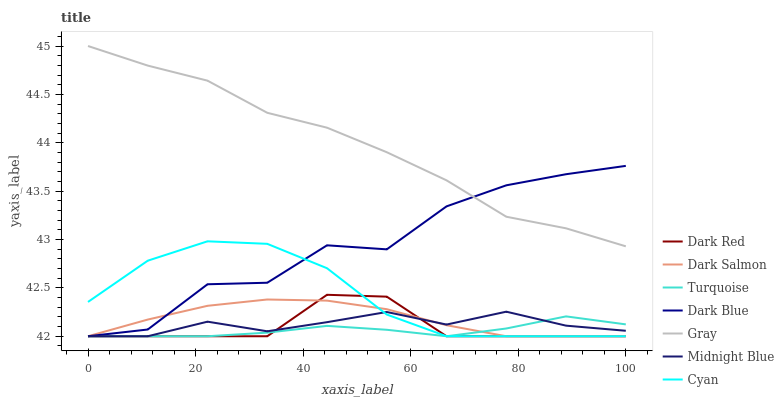Does Turquoise have the minimum area under the curve?
Answer yes or no. Yes. Does Gray have the maximum area under the curve?
Answer yes or no. Yes. Does Midnight Blue have the minimum area under the curve?
Answer yes or no. No. Does Midnight Blue have the maximum area under the curve?
Answer yes or no. No. Is Dark Salmon the smoothest?
Answer yes or no. Yes. Is Dark Blue the roughest?
Answer yes or no. Yes. Is Turquoise the smoothest?
Answer yes or no. No. Is Turquoise the roughest?
Answer yes or no. No. Does Turquoise have the lowest value?
Answer yes or no. Yes. Does Gray have the highest value?
Answer yes or no. Yes. Does Midnight Blue have the highest value?
Answer yes or no. No. Is Dark Salmon less than Gray?
Answer yes or no. Yes. Is Gray greater than Cyan?
Answer yes or no. Yes. Does Dark Blue intersect Dark Salmon?
Answer yes or no. Yes. Is Dark Blue less than Dark Salmon?
Answer yes or no. No. Is Dark Blue greater than Dark Salmon?
Answer yes or no. No. Does Dark Salmon intersect Gray?
Answer yes or no. No. 